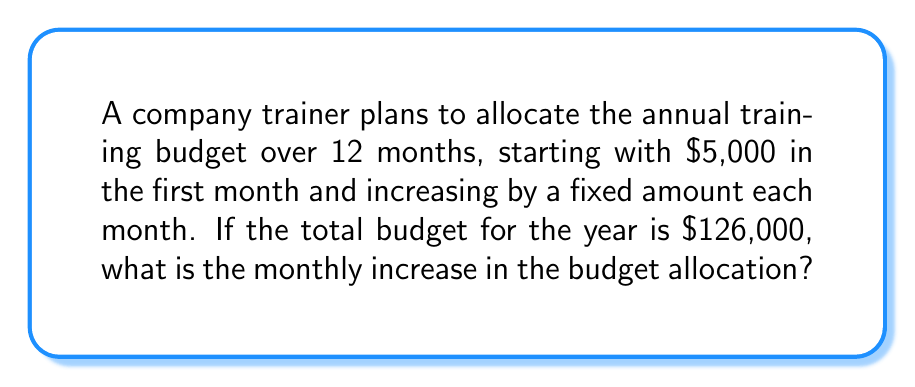Solve this math problem. Let's approach this step-by-step using arithmetic progression:

1) Let $a$ be the first term (initial budget) and $d$ be the common difference (monthly increase).
   We know $a = 5000$ and there are 12 terms (months).

2) The sum of an arithmetic progression is given by:
   $$S_n = \frac{n}{2}(a_1 + a_n)$$
   where $n$ is the number of terms, $a_1$ is the first term, and $a_n$ is the last term.

3) We know the sum $S_{12} = 126000$ and $n = 12$. We need to find $d$.

4) In an arithmetic progression, the last term is given by:
   $$a_n = a_1 + (n-1)d$$
   So, $a_{12} = 5000 + 11d$

5) Substituting into the sum formula:
   $$126000 = \frac{12}{2}(5000 + (5000 + 11d))$$

6) Simplifying:
   $$126000 = 6(10000 + 11d)$$
   $$126000 = 60000 + 66d$$

7) Solving for $d$:
   $$66d = 126000 - 60000 = 66000$$
   $$d = 1000$$

Thus, the monthly increase in budget allocation is $1,000.
Answer: $1,000 